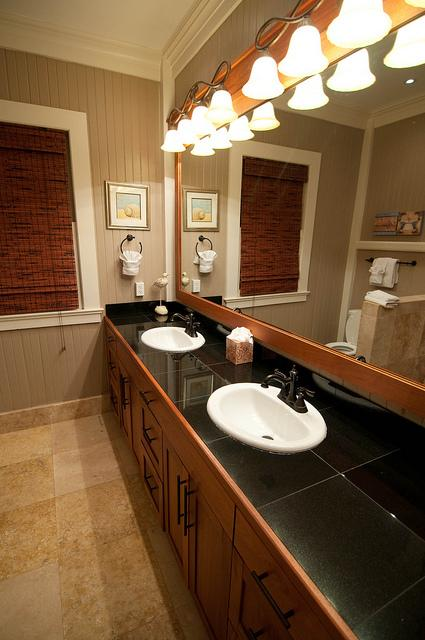What color are the sinks embedded in the black tile countertop? Please explain your reasoning. white. A white.  they are obviously white. 